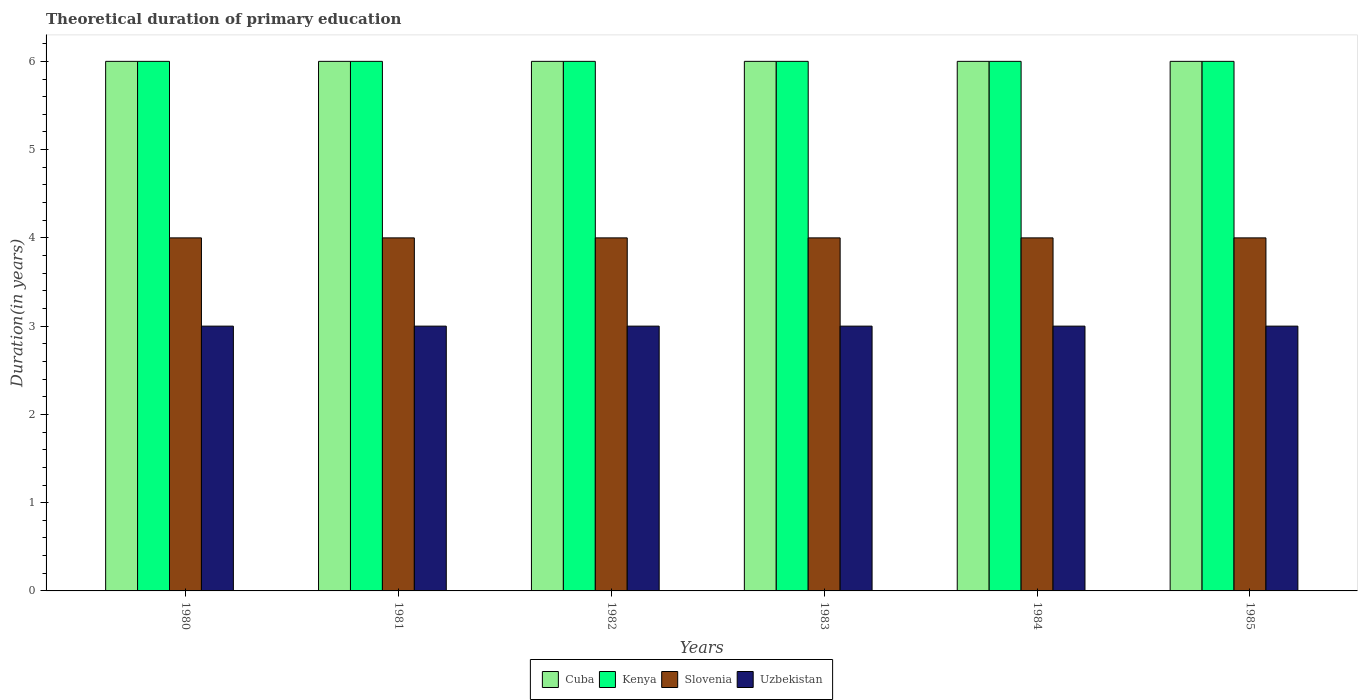In how many cases, is the number of bars for a given year not equal to the number of legend labels?
Keep it short and to the point. 0. What is the total theoretical duration of primary education in Uzbekistan in 1982?
Ensure brevity in your answer.  3. Across all years, what is the maximum total theoretical duration of primary education in Uzbekistan?
Make the answer very short. 3. In which year was the total theoretical duration of primary education in Cuba maximum?
Your response must be concise. 1980. In which year was the total theoretical duration of primary education in Cuba minimum?
Provide a succinct answer. 1980. What is the total total theoretical duration of primary education in Slovenia in the graph?
Give a very brief answer. 24. What is the difference between the total theoretical duration of primary education in Kenya in 1983 and the total theoretical duration of primary education in Cuba in 1984?
Provide a short and direct response. 0. In the year 1982, what is the difference between the total theoretical duration of primary education in Kenya and total theoretical duration of primary education in Cuba?
Ensure brevity in your answer.  0. In how many years, is the total theoretical duration of primary education in Kenya greater than 0.4 years?
Keep it short and to the point. 6. What is the ratio of the total theoretical duration of primary education in Uzbekistan in 1981 to that in 1985?
Provide a short and direct response. 1. Is the total theoretical duration of primary education in Slovenia in 1983 less than that in 1985?
Offer a terse response. No. Is the difference between the total theoretical duration of primary education in Kenya in 1980 and 1981 greater than the difference between the total theoretical duration of primary education in Cuba in 1980 and 1981?
Keep it short and to the point. No. Is the sum of the total theoretical duration of primary education in Kenya in 1981 and 1982 greater than the maximum total theoretical duration of primary education in Cuba across all years?
Make the answer very short. Yes. Is it the case that in every year, the sum of the total theoretical duration of primary education in Uzbekistan and total theoretical duration of primary education in Slovenia is greater than the sum of total theoretical duration of primary education in Cuba and total theoretical duration of primary education in Kenya?
Give a very brief answer. No. What does the 2nd bar from the left in 1985 represents?
Ensure brevity in your answer.  Kenya. What does the 3rd bar from the right in 1980 represents?
Your answer should be compact. Kenya. Is it the case that in every year, the sum of the total theoretical duration of primary education in Kenya and total theoretical duration of primary education in Slovenia is greater than the total theoretical duration of primary education in Cuba?
Your answer should be very brief. Yes. What is the difference between two consecutive major ticks on the Y-axis?
Keep it short and to the point. 1. Are the values on the major ticks of Y-axis written in scientific E-notation?
Give a very brief answer. No. Does the graph contain grids?
Ensure brevity in your answer.  No. How many legend labels are there?
Your answer should be compact. 4. How are the legend labels stacked?
Offer a very short reply. Horizontal. What is the title of the graph?
Offer a very short reply. Theoretical duration of primary education. Does "Guatemala" appear as one of the legend labels in the graph?
Give a very brief answer. No. What is the label or title of the Y-axis?
Your response must be concise. Duration(in years). What is the Duration(in years) of Kenya in 1980?
Make the answer very short. 6. What is the Duration(in years) of Slovenia in 1980?
Your answer should be very brief. 4. What is the Duration(in years) in Cuba in 1981?
Your answer should be compact. 6. What is the Duration(in years) of Kenya in 1981?
Provide a succinct answer. 6. What is the Duration(in years) of Slovenia in 1981?
Give a very brief answer. 4. What is the Duration(in years) in Cuba in 1982?
Keep it short and to the point. 6. What is the Duration(in years) of Cuba in 1983?
Provide a short and direct response. 6. What is the Duration(in years) of Slovenia in 1983?
Your answer should be very brief. 4. What is the Duration(in years) in Cuba in 1984?
Provide a short and direct response. 6. What is the Duration(in years) of Kenya in 1984?
Give a very brief answer. 6. What is the Duration(in years) in Slovenia in 1984?
Offer a very short reply. 4. What is the Duration(in years) of Uzbekistan in 1984?
Ensure brevity in your answer.  3. What is the Duration(in years) in Cuba in 1985?
Offer a terse response. 6. What is the Duration(in years) in Uzbekistan in 1985?
Offer a terse response. 3. Across all years, what is the minimum Duration(in years) in Kenya?
Make the answer very short. 6. What is the total Duration(in years) in Slovenia in the graph?
Your answer should be compact. 24. What is the total Duration(in years) of Uzbekistan in the graph?
Ensure brevity in your answer.  18. What is the difference between the Duration(in years) in Cuba in 1980 and that in 1981?
Your answer should be very brief. 0. What is the difference between the Duration(in years) of Cuba in 1980 and that in 1982?
Provide a short and direct response. 0. What is the difference between the Duration(in years) in Kenya in 1980 and that in 1982?
Your answer should be very brief. 0. What is the difference between the Duration(in years) in Slovenia in 1980 and that in 1982?
Give a very brief answer. 0. What is the difference between the Duration(in years) of Cuba in 1980 and that in 1983?
Provide a short and direct response. 0. What is the difference between the Duration(in years) of Kenya in 1980 and that in 1984?
Your answer should be very brief. 0. What is the difference between the Duration(in years) of Slovenia in 1980 and that in 1984?
Ensure brevity in your answer.  0. What is the difference between the Duration(in years) of Cuba in 1980 and that in 1985?
Your answer should be compact. 0. What is the difference between the Duration(in years) of Uzbekistan in 1980 and that in 1985?
Ensure brevity in your answer.  0. What is the difference between the Duration(in years) in Cuba in 1981 and that in 1982?
Provide a succinct answer. 0. What is the difference between the Duration(in years) of Slovenia in 1981 and that in 1982?
Make the answer very short. 0. What is the difference between the Duration(in years) in Uzbekistan in 1981 and that in 1982?
Ensure brevity in your answer.  0. What is the difference between the Duration(in years) of Uzbekistan in 1981 and that in 1983?
Your answer should be compact. 0. What is the difference between the Duration(in years) in Kenya in 1981 and that in 1984?
Provide a succinct answer. 0. What is the difference between the Duration(in years) in Uzbekistan in 1981 and that in 1984?
Provide a succinct answer. 0. What is the difference between the Duration(in years) of Cuba in 1981 and that in 1985?
Offer a very short reply. 0. What is the difference between the Duration(in years) in Uzbekistan in 1981 and that in 1985?
Ensure brevity in your answer.  0. What is the difference between the Duration(in years) in Cuba in 1982 and that in 1983?
Provide a succinct answer. 0. What is the difference between the Duration(in years) of Slovenia in 1982 and that in 1983?
Offer a terse response. 0. What is the difference between the Duration(in years) in Cuba in 1982 and that in 1984?
Provide a succinct answer. 0. What is the difference between the Duration(in years) of Kenya in 1982 and that in 1984?
Your answer should be compact. 0. What is the difference between the Duration(in years) in Uzbekistan in 1982 and that in 1984?
Your answer should be compact. 0. What is the difference between the Duration(in years) of Cuba in 1982 and that in 1985?
Ensure brevity in your answer.  0. What is the difference between the Duration(in years) of Kenya in 1982 and that in 1985?
Your answer should be very brief. 0. What is the difference between the Duration(in years) of Uzbekistan in 1982 and that in 1985?
Keep it short and to the point. 0. What is the difference between the Duration(in years) in Kenya in 1983 and that in 1984?
Offer a very short reply. 0. What is the difference between the Duration(in years) in Slovenia in 1983 and that in 1985?
Your answer should be compact. 0. What is the difference between the Duration(in years) in Cuba in 1984 and that in 1985?
Your answer should be compact. 0. What is the difference between the Duration(in years) in Slovenia in 1984 and that in 1985?
Your response must be concise. 0. What is the difference between the Duration(in years) in Uzbekistan in 1984 and that in 1985?
Your response must be concise. 0. What is the difference between the Duration(in years) of Cuba in 1980 and the Duration(in years) of Kenya in 1981?
Keep it short and to the point. 0. What is the difference between the Duration(in years) in Cuba in 1980 and the Duration(in years) in Slovenia in 1981?
Your answer should be very brief. 2. What is the difference between the Duration(in years) of Kenya in 1980 and the Duration(in years) of Slovenia in 1981?
Your answer should be very brief. 2. What is the difference between the Duration(in years) of Cuba in 1980 and the Duration(in years) of Kenya in 1982?
Provide a short and direct response. 0. What is the difference between the Duration(in years) in Cuba in 1980 and the Duration(in years) in Uzbekistan in 1982?
Your response must be concise. 3. What is the difference between the Duration(in years) of Kenya in 1980 and the Duration(in years) of Slovenia in 1982?
Keep it short and to the point. 2. What is the difference between the Duration(in years) in Kenya in 1980 and the Duration(in years) in Uzbekistan in 1982?
Keep it short and to the point. 3. What is the difference between the Duration(in years) in Cuba in 1980 and the Duration(in years) in Uzbekistan in 1983?
Your answer should be very brief. 3. What is the difference between the Duration(in years) of Kenya in 1980 and the Duration(in years) of Slovenia in 1983?
Ensure brevity in your answer.  2. What is the difference between the Duration(in years) of Kenya in 1980 and the Duration(in years) of Uzbekistan in 1983?
Your answer should be very brief. 3. What is the difference between the Duration(in years) of Cuba in 1980 and the Duration(in years) of Slovenia in 1984?
Provide a succinct answer. 2. What is the difference between the Duration(in years) in Cuba in 1980 and the Duration(in years) in Uzbekistan in 1984?
Your answer should be very brief. 3. What is the difference between the Duration(in years) in Kenya in 1980 and the Duration(in years) in Slovenia in 1984?
Make the answer very short. 2. What is the difference between the Duration(in years) of Kenya in 1980 and the Duration(in years) of Uzbekistan in 1984?
Your answer should be compact. 3. What is the difference between the Duration(in years) of Slovenia in 1980 and the Duration(in years) of Uzbekistan in 1984?
Provide a short and direct response. 1. What is the difference between the Duration(in years) in Cuba in 1980 and the Duration(in years) in Kenya in 1985?
Make the answer very short. 0. What is the difference between the Duration(in years) in Cuba in 1980 and the Duration(in years) in Uzbekistan in 1985?
Provide a succinct answer. 3. What is the difference between the Duration(in years) of Slovenia in 1980 and the Duration(in years) of Uzbekistan in 1985?
Offer a terse response. 1. What is the difference between the Duration(in years) in Cuba in 1981 and the Duration(in years) in Kenya in 1982?
Make the answer very short. 0. What is the difference between the Duration(in years) in Slovenia in 1981 and the Duration(in years) in Uzbekistan in 1982?
Offer a very short reply. 1. What is the difference between the Duration(in years) in Cuba in 1981 and the Duration(in years) in Kenya in 1983?
Your answer should be very brief. 0. What is the difference between the Duration(in years) of Cuba in 1981 and the Duration(in years) of Slovenia in 1983?
Provide a short and direct response. 2. What is the difference between the Duration(in years) of Cuba in 1981 and the Duration(in years) of Uzbekistan in 1983?
Give a very brief answer. 3. What is the difference between the Duration(in years) of Cuba in 1981 and the Duration(in years) of Slovenia in 1984?
Provide a short and direct response. 2. What is the difference between the Duration(in years) of Cuba in 1981 and the Duration(in years) of Uzbekistan in 1984?
Your answer should be compact. 3. What is the difference between the Duration(in years) in Slovenia in 1981 and the Duration(in years) in Uzbekistan in 1984?
Make the answer very short. 1. What is the difference between the Duration(in years) in Cuba in 1981 and the Duration(in years) in Slovenia in 1985?
Your answer should be very brief. 2. What is the difference between the Duration(in years) of Cuba in 1981 and the Duration(in years) of Uzbekistan in 1985?
Ensure brevity in your answer.  3. What is the difference between the Duration(in years) of Cuba in 1982 and the Duration(in years) of Uzbekistan in 1983?
Ensure brevity in your answer.  3. What is the difference between the Duration(in years) of Kenya in 1982 and the Duration(in years) of Slovenia in 1983?
Offer a terse response. 2. What is the difference between the Duration(in years) of Kenya in 1982 and the Duration(in years) of Uzbekistan in 1983?
Your answer should be very brief. 3. What is the difference between the Duration(in years) of Kenya in 1982 and the Duration(in years) of Slovenia in 1984?
Offer a very short reply. 2. What is the difference between the Duration(in years) of Cuba in 1982 and the Duration(in years) of Kenya in 1985?
Provide a succinct answer. 0. What is the difference between the Duration(in years) of Cuba in 1982 and the Duration(in years) of Slovenia in 1985?
Your response must be concise. 2. What is the difference between the Duration(in years) of Cuba in 1982 and the Duration(in years) of Uzbekistan in 1985?
Offer a terse response. 3. What is the difference between the Duration(in years) in Kenya in 1982 and the Duration(in years) in Uzbekistan in 1985?
Give a very brief answer. 3. What is the difference between the Duration(in years) of Slovenia in 1982 and the Duration(in years) of Uzbekistan in 1985?
Keep it short and to the point. 1. What is the difference between the Duration(in years) in Cuba in 1983 and the Duration(in years) in Kenya in 1984?
Your answer should be very brief. 0. What is the difference between the Duration(in years) in Slovenia in 1983 and the Duration(in years) in Uzbekistan in 1984?
Ensure brevity in your answer.  1. What is the difference between the Duration(in years) of Cuba in 1983 and the Duration(in years) of Slovenia in 1985?
Give a very brief answer. 2. What is the difference between the Duration(in years) of Cuba in 1983 and the Duration(in years) of Uzbekistan in 1985?
Your answer should be very brief. 3. What is the difference between the Duration(in years) of Kenya in 1983 and the Duration(in years) of Slovenia in 1985?
Ensure brevity in your answer.  2. What is the difference between the Duration(in years) in Kenya in 1983 and the Duration(in years) in Uzbekistan in 1985?
Your response must be concise. 3. What is the difference between the Duration(in years) in Slovenia in 1983 and the Duration(in years) in Uzbekistan in 1985?
Keep it short and to the point. 1. What is the difference between the Duration(in years) in Cuba in 1984 and the Duration(in years) in Slovenia in 1985?
Your answer should be very brief. 2. What is the difference between the Duration(in years) of Kenya in 1984 and the Duration(in years) of Slovenia in 1985?
Give a very brief answer. 2. What is the average Duration(in years) in Cuba per year?
Offer a very short reply. 6. What is the average Duration(in years) in Slovenia per year?
Your answer should be compact. 4. What is the average Duration(in years) in Uzbekistan per year?
Offer a terse response. 3. In the year 1980, what is the difference between the Duration(in years) of Cuba and Duration(in years) of Uzbekistan?
Provide a short and direct response. 3. In the year 1980, what is the difference between the Duration(in years) in Slovenia and Duration(in years) in Uzbekistan?
Your answer should be very brief. 1. In the year 1981, what is the difference between the Duration(in years) of Cuba and Duration(in years) of Kenya?
Ensure brevity in your answer.  0. In the year 1981, what is the difference between the Duration(in years) in Cuba and Duration(in years) in Uzbekistan?
Offer a very short reply. 3. In the year 1981, what is the difference between the Duration(in years) of Kenya and Duration(in years) of Slovenia?
Offer a very short reply. 2. In the year 1981, what is the difference between the Duration(in years) of Kenya and Duration(in years) of Uzbekistan?
Your answer should be very brief. 3. In the year 1981, what is the difference between the Duration(in years) in Slovenia and Duration(in years) in Uzbekistan?
Keep it short and to the point. 1. In the year 1982, what is the difference between the Duration(in years) of Cuba and Duration(in years) of Kenya?
Give a very brief answer. 0. In the year 1982, what is the difference between the Duration(in years) of Cuba and Duration(in years) of Slovenia?
Make the answer very short. 2. In the year 1982, what is the difference between the Duration(in years) in Cuba and Duration(in years) in Uzbekistan?
Provide a succinct answer. 3. In the year 1982, what is the difference between the Duration(in years) in Kenya and Duration(in years) in Slovenia?
Give a very brief answer. 2. In the year 1982, what is the difference between the Duration(in years) in Slovenia and Duration(in years) in Uzbekistan?
Offer a terse response. 1. In the year 1983, what is the difference between the Duration(in years) in Cuba and Duration(in years) in Kenya?
Your answer should be very brief. 0. In the year 1983, what is the difference between the Duration(in years) of Cuba and Duration(in years) of Slovenia?
Provide a succinct answer. 2. In the year 1983, what is the difference between the Duration(in years) of Cuba and Duration(in years) of Uzbekistan?
Your answer should be very brief. 3. In the year 1983, what is the difference between the Duration(in years) in Kenya and Duration(in years) in Slovenia?
Your answer should be very brief. 2. In the year 1984, what is the difference between the Duration(in years) in Cuba and Duration(in years) in Slovenia?
Give a very brief answer. 2. In the year 1984, what is the difference between the Duration(in years) of Cuba and Duration(in years) of Uzbekistan?
Give a very brief answer. 3. In the year 1984, what is the difference between the Duration(in years) of Kenya and Duration(in years) of Uzbekistan?
Make the answer very short. 3. In the year 1984, what is the difference between the Duration(in years) of Slovenia and Duration(in years) of Uzbekistan?
Your response must be concise. 1. In the year 1985, what is the difference between the Duration(in years) in Cuba and Duration(in years) in Slovenia?
Provide a short and direct response. 2. In the year 1985, what is the difference between the Duration(in years) of Cuba and Duration(in years) of Uzbekistan?
Your answer should be compact. 3. In the year 1985, what is the difference between the Duration(in years) of Kenya and Duration(in years) of Slovenia?
Give a very brief answer. 2. In the year 1985, what is the difference between the Duration(in years) of Kenya and Duration(in years) of Uzbekistan?
Provide a succinct answer. 3. In the year 1985, what is the difference between the Duration(in years) of Slovenia and Duration(in years) of Uzbekistan?
Ensure brevity in your answer.  1. What is the ratio of the Duration(in years) in Kenya in 1980 to that in 1981?
Provide a succinct answer. 1. What is the ratio of the Duration(in years) in Slovenia in 1980 to that in 1981?
Ensure brevity in your answer.  1. What is the ratio of the Duration(in years) in Kenya in 1980 to that in 1982?
Provide a short and direct response. 1. What is the ratio of the Duration(in years) in Cuba in 1980 to that in 1983?
Offer a very short reply. 1. What is the ratio of the Duration(in years) of Kenya in 1980 to that in 1983?
Give a very brief answer. 1. What is the ratio of the Duration(in years) of Uzbekistan in 1980 to that in 1983?
Ensure brevity in your answer.  1. What is the ratio of the Duration(in years) in Cuba in 1980 to that in 1984?
Your response must be concise. 1. What is the ratio of the Duration(in years) of Kenya in 1980 to that in 1984?
Ensure brevity in your answer.  1. What is the ratio of the Duration(in years) in Slovenia in 1980 to that in 1984?
Keep it short and to the point. 1. What is the ratio of the Duration(in years) of Cuba in 1980 to that in 1985?
Provide a short and direct response. 1. What is the ratio of the Duration(in years) in Uzbekistan in 1980 to that in 1985?
Your response must be concise. 1. What is the ratio of the Duration(in years) in Cuba in 1981 to that in 1982?
Offer a very short reply. 1. What is the ratio of the Duration(in years) of Kenya in 1981 to that in 1982?
Ensure brevity in your answer.  1. What is the ratio of the Duration(in years) in Uzbekistan in 1981 to that in 1982?
Your answer should be very brief. 1. What is the ratio of the Duration(in years) in Cuba in 1981 to that in 1983?
Give a very brief answer. 1. What is the ratio of the Duration(in years) in Kenya in 1981 to that in 1983?
Make the answer very short. 1. What is the ratio of the Duration(in years) of Slovenia in 1981 to that in 1983?
Provide a short and direct response. 1. What is the ratio of the Duration(in years) in Kenya in 1981 to that in 1984?
Make the answer very short. 1. What is the ratio of the Duration(in years) of Uzbekistan in 1981 to that in 1984?
Provide a succinct answer. 1. What is the ratio of the Duration(in years) in Cuba in 1981 to that in 1985?
Your answer should be compact. 1. What is the ratio of the Duration(in years) in Kenya in 1981 to that in 1985?
Your answer should be very brief. 1. What is the ratio of the Duration(in years) in Cuba in 1982 to that in 1983?
Ensure brevity in your answer.  1. What is the ratio of the Duration(in years) in Kenya in 1982 to that in 1983?
Keep it short and to the point. 1. What is the ratio of the Duration(in years) in Cuba in 1982 to that in 1984?
Keep it short and to the point. 1. What is the ratio of the Duration(in years) of Kenya in 1982 to that in 1984?
Provide a short and direct response. 1. What is the ratio of the Duration(in years) of Slovenia in 1982 to that in 1984?
Your response must be concise. 1. What is the ratio of the Duration(in years) of Uzbekistan in 1982 to that in 1984?
Your answer should be very brief. 1. What is the ratio of the Duration(in years) in Cuba in 1982 to that in 1985?
Provide a succinct answer. 1. What is the ratio of the Duration(in years) of Kenya in 1982 to that in 1985?
Provide a short and direct response. 1. What is the ratio of the Duration(in years) in Uzbekistan in 1982 to that in 1985?
Keep it short and to the point. 1. What is the ratio of the Duration(in years) in Kenya in 1983 to that in 1984?
Give a very brief answer. 1. What is the ratio of the Duration(in years) of Slovenia in 1983 to that in 1984?
Your response must be concise. 1. What is the ratio of the Duration(in years) in Uzbekistan in 1983 to that in 1984?
Offer a very short reply. 1. What is the ratio of the Duration(in years) in Slovenia in 1983 to that in 1985?
Provide a short and direct response. 1. What is the ratio of the Duration(in years) of Uzbekistan in 1983 to that in 1985?
Offer a terse response. 1. What is the ratio of the Duration(in years) in Kenya in 1984 to that in 1985?
Keep it short and to the point. 1. What is the ratio of the Duration(in years) in Slovenia in 1984 to that in 1985?
Your response must be concise. 1. What is the difference between the highest and the second highest Duration(in years) of Slovenia?
Your answer should be very brief. 0. What is the difference between the highest and the lowest Duration(in years) of Slovenia?
Give a very brief answer. 0. What is the difference between the highest and the lowest Duration(in years) of Uzbekistan?
Offer a very short reply. 0. 